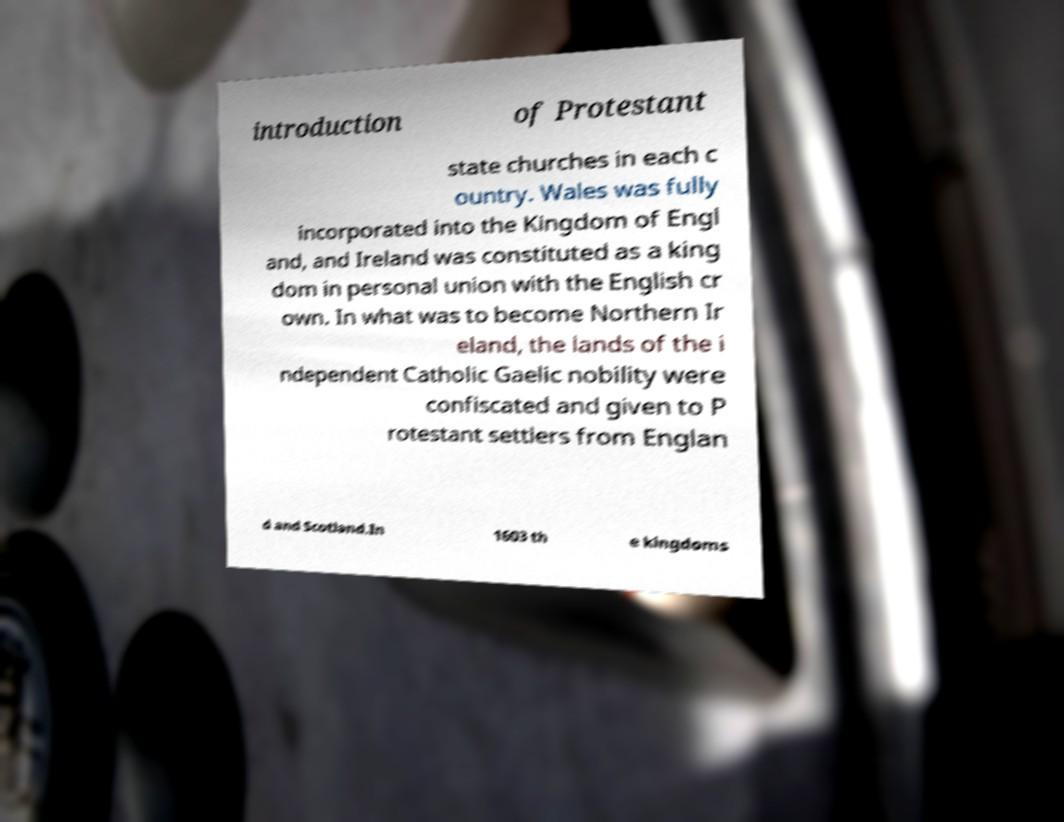Can you read and provide the text displayed in the image?This photo seems to have some interesting text. Can you extract and type it out for me? introduction of Protestant state churches in each c ountry. Wales was fully incorporated into the Kingdom of Engl and, and Ireland was constituted as a king dom in personal union with the English cr own. In what was to become Northern Ir eland, the lands of the i ndependent Catholic Gaelic nobility were confiscated and given to P rotestant settlers from Englan d and Scotland.In 1603 th e kingdoms 